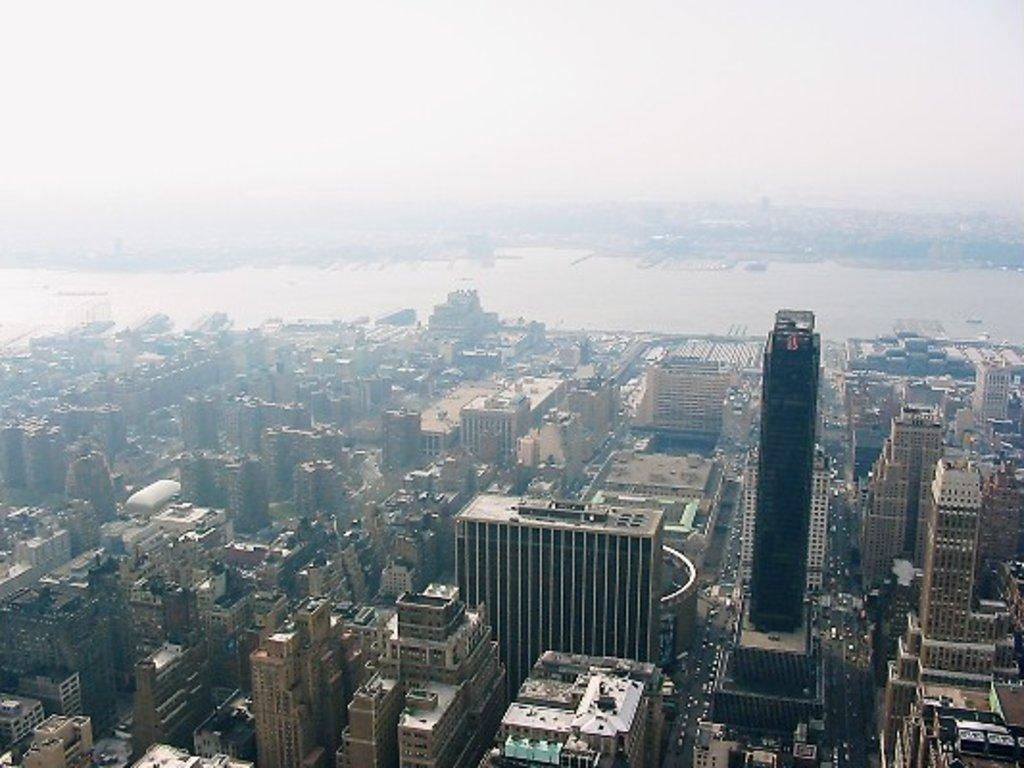Can you describe this image briefly? Here we can see buildings, vehicles, and water. In the background there is sky. 